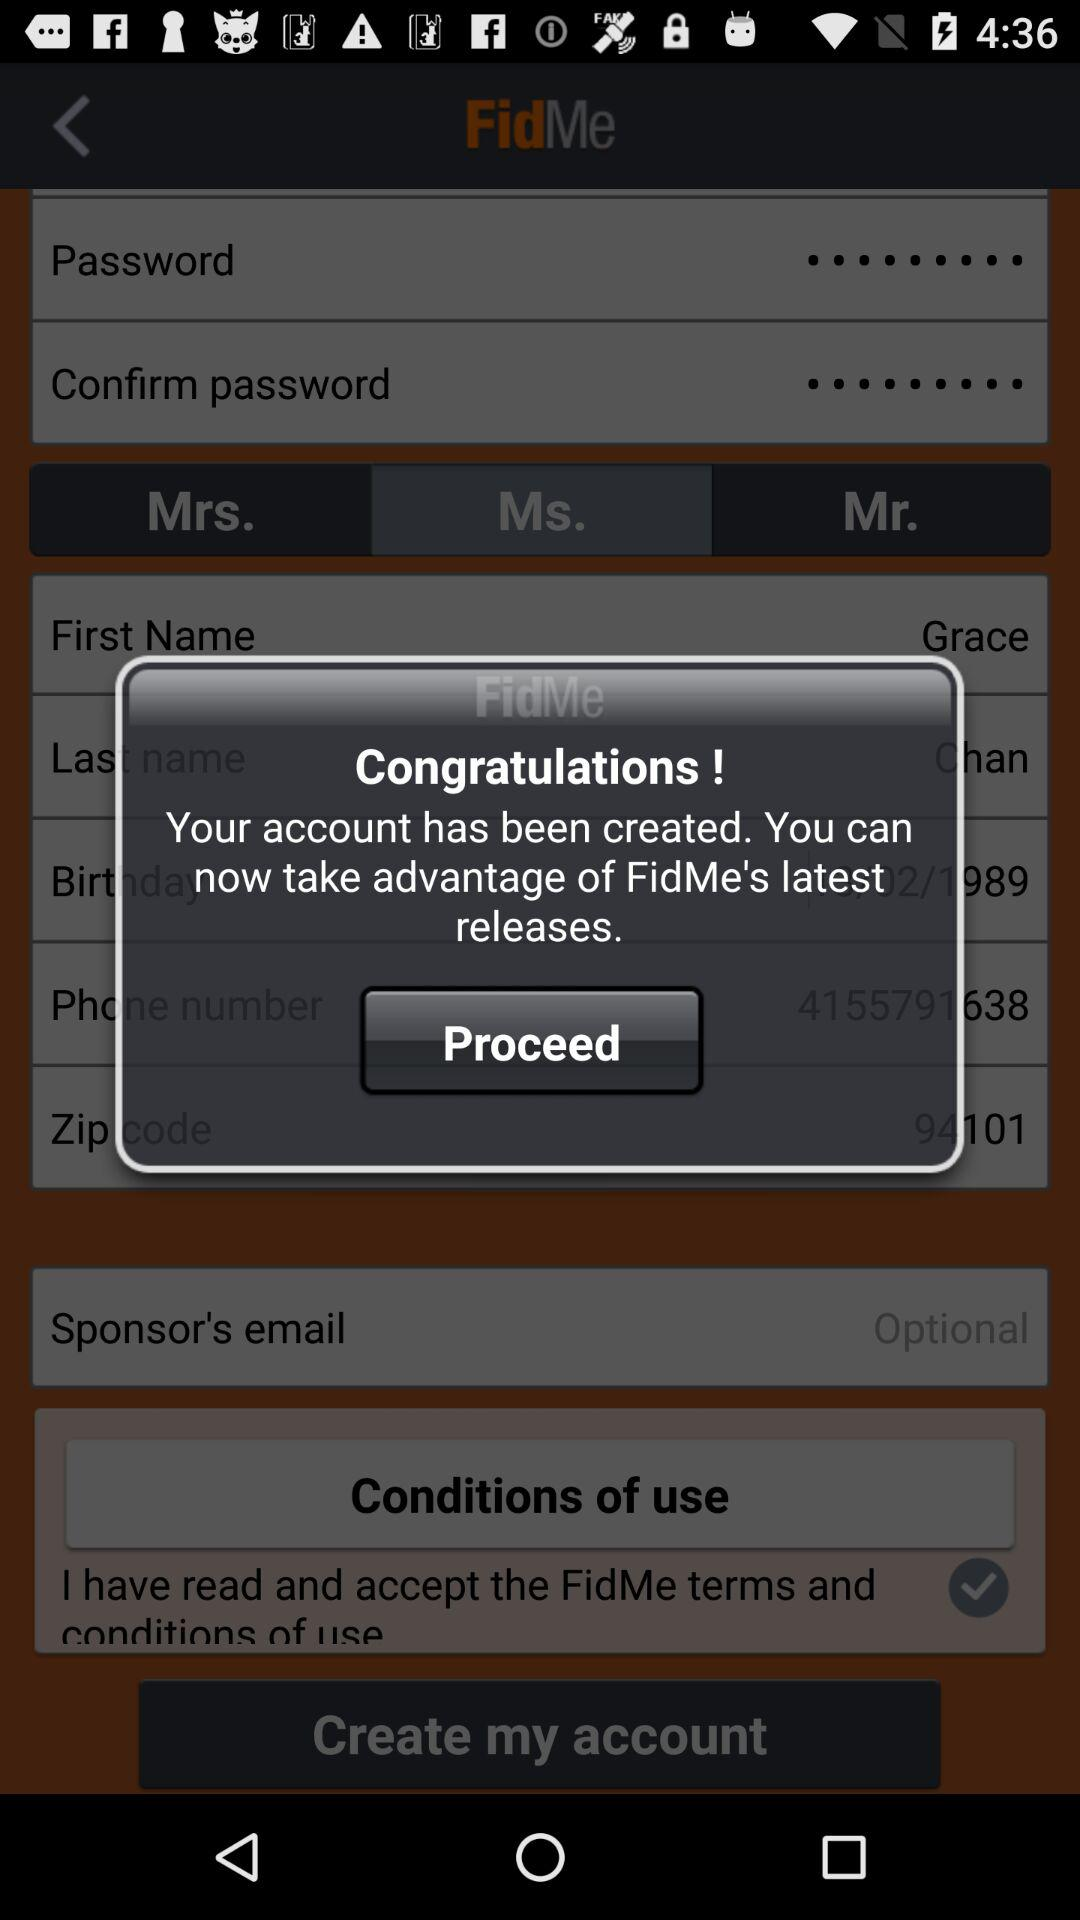What is the application name? The application name is "FidMe". 